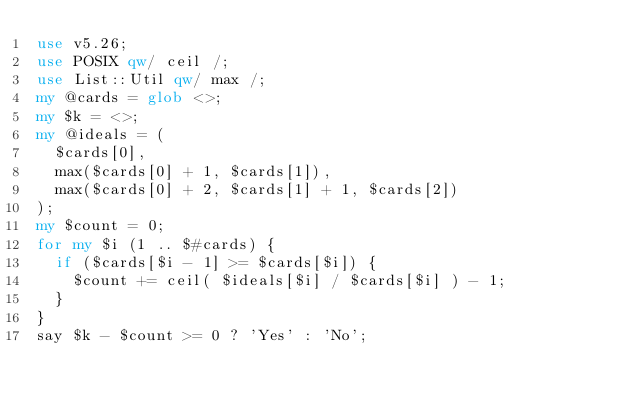Convert code to text. <code><loc_0><loc_0><loc_500><loc_500><_Perl_>use v5.26;
use POSIX qw/ ceil /;
use List::Util qw/ max /;
my @cards = glob <>;
my $k = <>;
my @ideals = (
  $cards[0],
  max($cards[0] + 1, $cards[1]),
  max($cards[0] + 2, $cards[1] + 1, $cards[2])
);
my $count = 0;
for my $i (1 .. $#cards) {
  if ($cards[$i - 1] >= $cards[$i]) {
    $count += ceil( $ideals[$i] / $cards[$i] ) - 1;
  }
}
say $k - $count >= 0 ? 'Yes' : 'No';</code> 